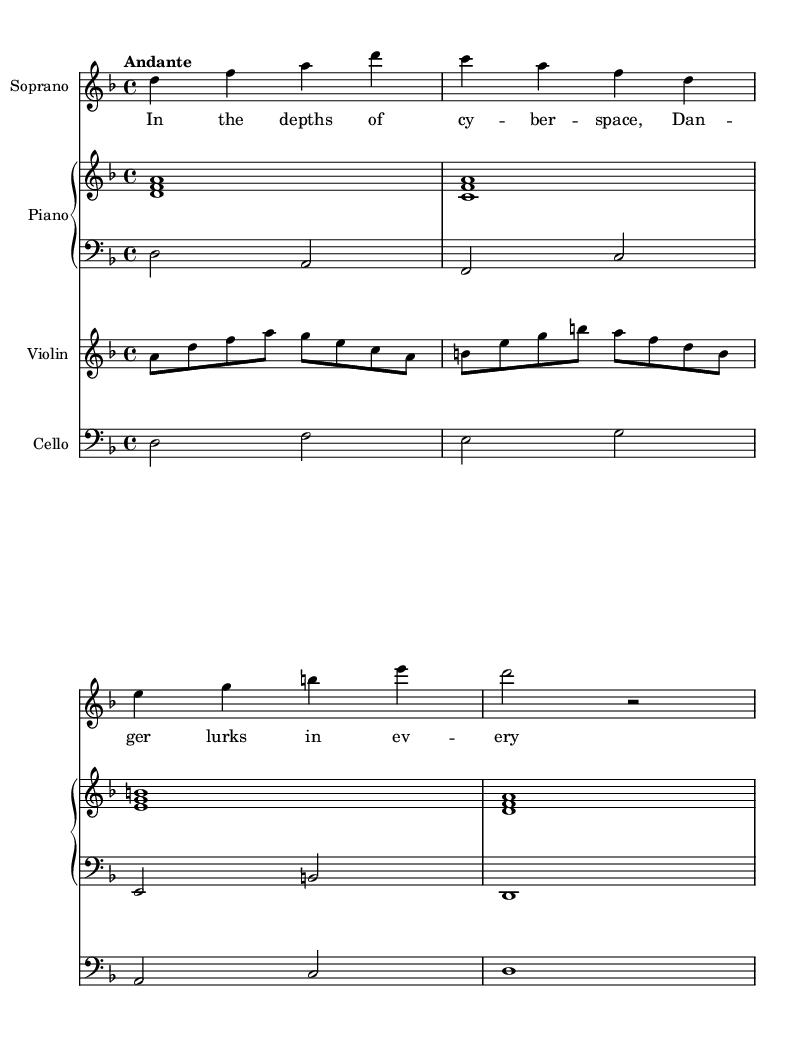What is the key signature of this music? The key signature is represented by the notes and symbols indicated at the beginning of the staff. In this case, the music is in D minor, which is identified by one flat (B flat).
Answer: D minor What is the time signature of this music? The time signature can be found at the beginning of the score, signifying how many beats are in each measure and what note value is equivalent to one beat. Here, it is 4/4, meaning there are four beats per measure and the quarter note gets one beat.
Answer: 4/4 What is the tempo marking for this piece? The tempo marking indicates the speed of the music and is usually placed near the beginning of the score. In this case, "Andante" suggests a moderately slow tempo.
Answer: Andante How many staves are utilized in the score? By examining the layout of the score, we can count the visible staves. There is one staff for the soprano, one for the piano (which has two staves), one for the violin, and one for the cello, making a total of five staves.
Answer: Five staves Which voice part has lyrics written? The only voice part that contains lyrics in the score is the soprano, as indicated by the lyrics aligned directly beneath its notes.
Answer: Soprano What instrument plays the bass line? The bass line in this score is played by the cello, which is indicated by its specific staff that is set in the bass clef.
Answer: Cello What is the first note of the soprano part? The first note of the soprano part can be found at the beginning of the voiced staff, which is a D. This is confirmed by looking at the initial notes recorded in the soprano section.
Answer: D 